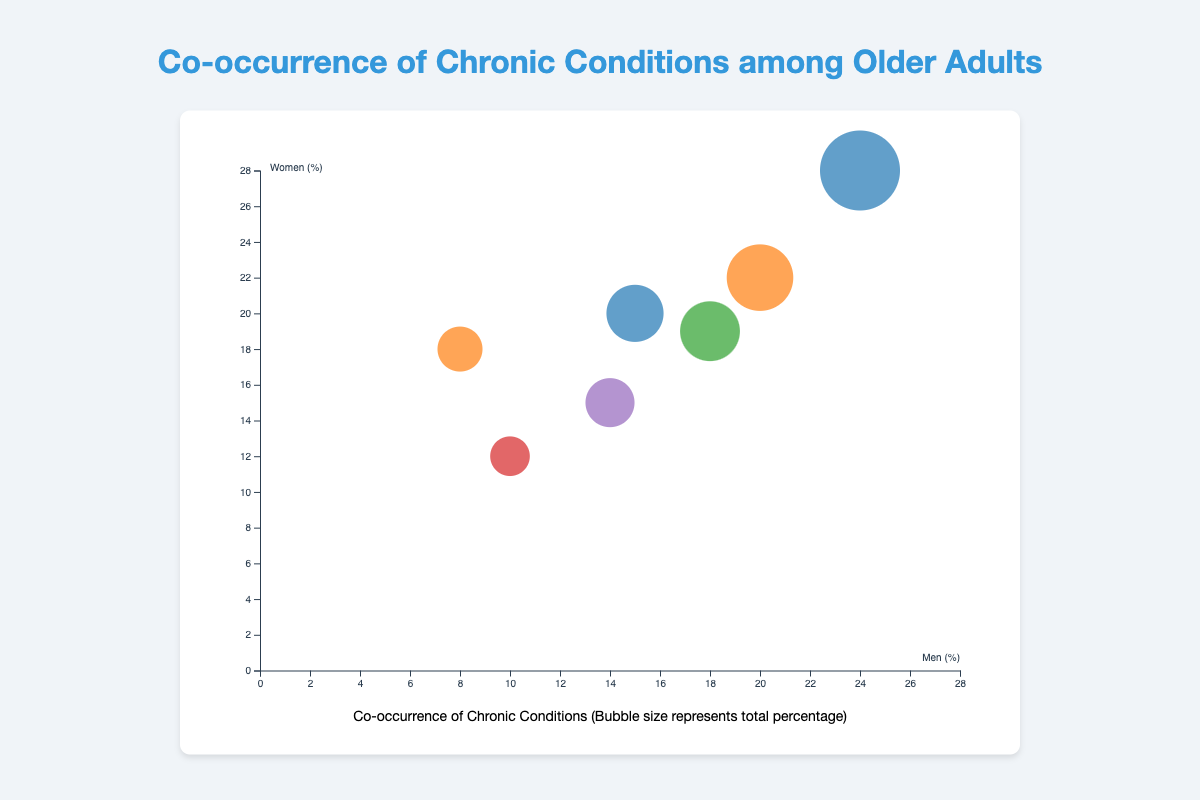How many bubbles are there in the chart? Count the total number of bubbles visible in the chart.
Answer: 7 Which pair of conditions has the largest bubble size? Identify the bubble with the biggest radius, indicating the condition pair with the highest co-occurrence value.
Answer: Hypertension & Diabetes What is the percentage difference in the co-occurrence of Arthritis & Osteoporosis between men and women? Subtract the percentage of men from the percentage of women for Arthritis & Osteoporosis. The values are 18% (women) and 8% (men).
Answer: 10% Which pair of conditions shows a higher prevalence in men compared to women? Compare all condition pairs to see in which cases men's percentages are greater than women's. One example is Arthritis & Heart Disease where men have 20% and women have 22%.
Answer: None What is the bubble size for the Heart Disease & Obesity pair? Look for the bubble representing Heart Disease & Obesity and identify its size from the data.
Answer: 29 Which pair of conditions with Hypertension as one of the conditions has the highest co-occurrence among women? Among the condition pairs with Hypertension, compare the women's percentages. Hypertension & Diabetes has 28% women, Hypertension & Cancer has 20% women, and Chronic Kidney Disease & Hypertension has 19% women.
Answer: Hypertension & Diabetes Which gender has a higher percentage of co-occurrence for the Heart Disease & Obesity combination? Look at the percentages for men and women for Heart Disease & Obesity, which are 14% for men and 15% for women.
Answer: Women What is the average percentage of co-occurrence for men across all condition pairs? Sum up the men's percentages for all condition pairs and divide by the number of pairs. (24+20+18+15+10+8+14)/7 ≈ 15.57
Answer: 15.57% Are there more bubbles where men or women have higher percentages? Count the bubbles where men's percentages are higher and count where women's percentages are higher, then compare the counts.
Answer: More in women (7 bubbles where women have higher percentages) 